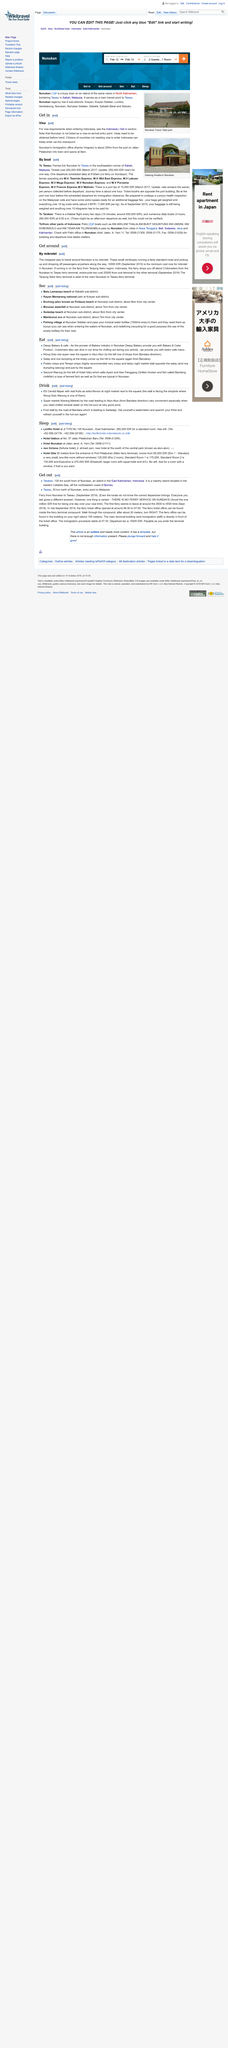Draw attention to some important aspects in this diagram. Nunukan is not listed as a visa-on-arrival entry point. Nunukan's Immigration office opens at 8am every day. The Nunukan Immigration office is approximately 200 meters from the port on Jalan Pelabuhan in Nunukan. 